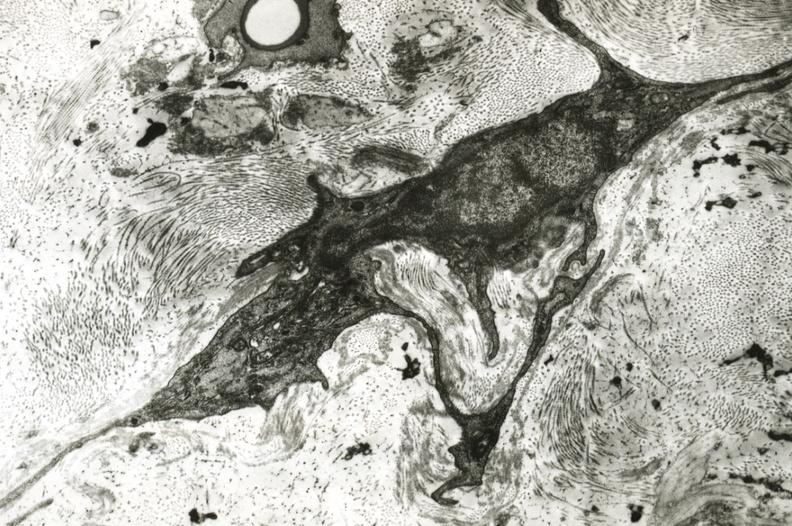does this image show fibroblasts in adventitia of monkey basilar artery?
Answer the question using a single word or phrase. Yes 